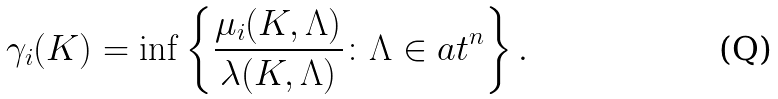Convert formula to latex. <formula><loc_0><loc_0><loc_500><loc_500>\gamma _ { i } ( K ) = \inf \left \{ \frac { \mu _ { i } ( K , \Lambda ) } { \lambda ( K , \Lambda ) } \colon \Lambda \in \L a t ^ { n } \right \} .</formula> 